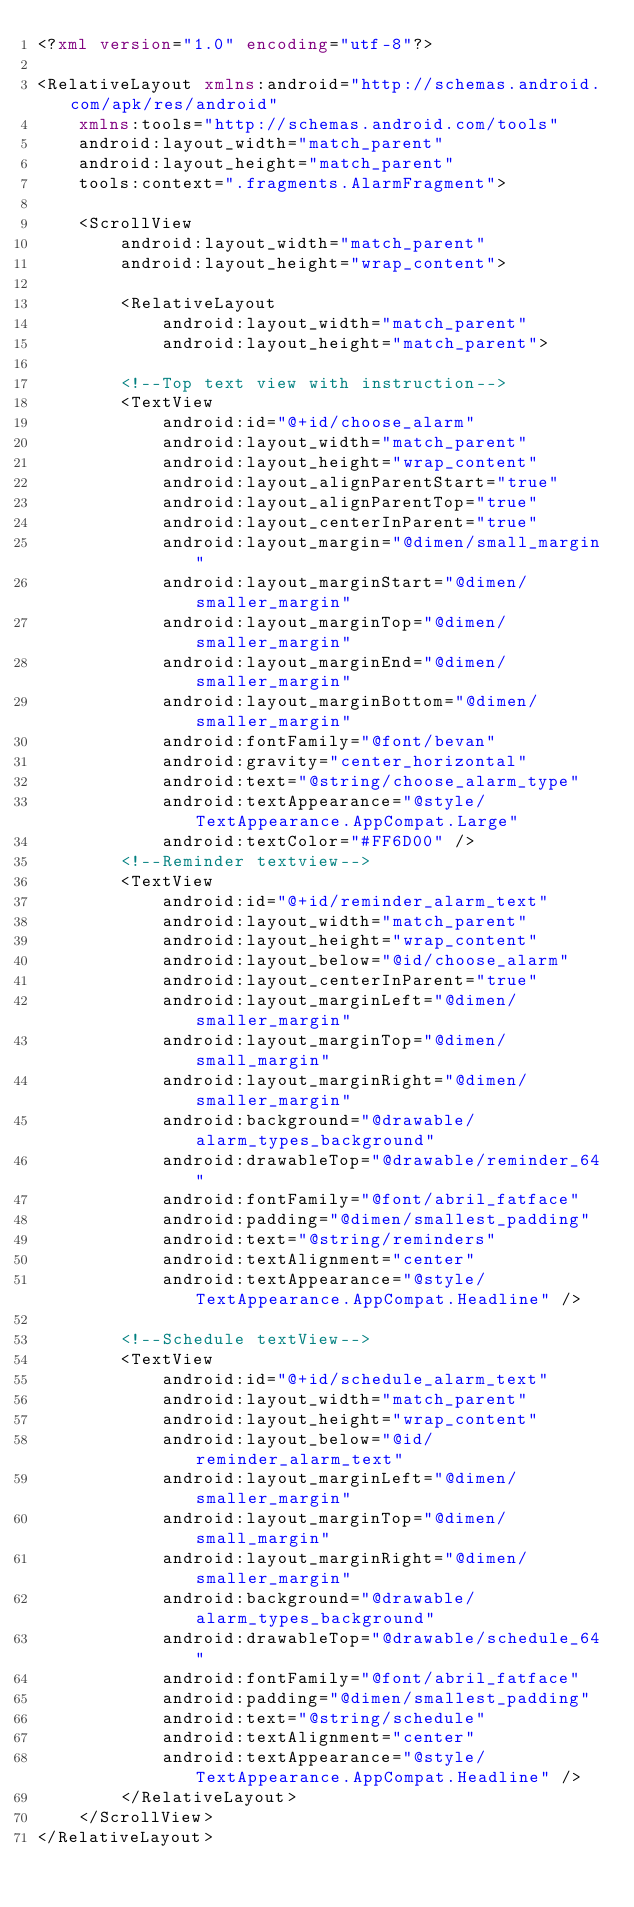Convert code to text. <code><loc_0><loc_0><loc_500><loc_500><_XML_><?xml version="1.0" encoding="utf-8"?>

<RelativeLayout xmlns:android="http://schemas.android.com/apk/res/android"
    xmlns:tools="http://schemas.android.com/tools"
    android:layout_width="match_parent"
    android:layout_height="match_parent"
    tools:context=".fragments.AlarmFragment">

    <ScrollView
        android:layout_width="match_parent"
        android:layout_height="wrap_content">

        <RelativeLayout
            android:layout_width="match_parent"
            android:layout_height="match_parent">

        <!--Top text view with instruction-->
        <TextView
            android:id="@+id/choose_alarm"
            android:layout_width="match_parent"
            android:layout_height="wrap_content"
            android:layout_alignParentStart="true"
            android:layout_alignParentTop="true"
            android:layout_centerInParent="true"
            android:layout_margin="@dimen/small_margin"
            android:layout_marginStart="@dimen/smaller_margin"
            android:layout_marginTop="@dimen/smaller_margin"
            android:layout_marginEnd="@dimen/smaller_margin"
            android:layout_marginBottom="@dimen/smaller_margin"
            android:fontFamily="@font/bevan"
            android:gravity="center_horizontal"
            android:text="@string/choose_alarm_type"
            android:textAppearance="@style/TextAppearance.AppCompat.Large"
            android:textColor="#FF6D00" />
        <!--Reminder textview-->
        <TextView
            android:id="@+id/reminder_alarm_text"
            android:layout_width="match_parent"
            android:layout_height="wrap_content"
            android:layout_below="@id/choose_alarm"
            android:layout_centerInParent="true"
            android:layout_marginLeft="@dimen/smaller_margin"
            android:layout_marginTop="@dimen/small_margin"
            android:layout_marginRight="@dimen/smaller_margin"
            android:background="@drawable/alarm_types_background"
            android:drawableTop="@drawable/reminder_64"
            android:fontFamily="@font/abril_fatface"
            android:padding="@dimen/smallest_padding"
            android:text="@string/reminders"
            android:textAlignment="center"
            android:textAppearance="@style/TextAppearance.AppCompat.Headline" />

        <!--Schedule textView-->
        <TextView
            android:id="@+id/schedule_alarm_text"
            android:layout_width="match_parent"
            android:layout_height="wrap_content"
            android:layout_below="@id/reminder_alarm_text"
            android:layout_marginLeft="@dimen/smaller_margin"
            android:layout_marginTop="@dimen/small_margin"
            android:layout_marginRight="@dimen/smaller_margin"
            android:background="@drawable/alarm_types_background"
            android:drawableTop="@drawable/schedule_64"
            android:fontFamily="@font/abril_fatface"
            android:padding="@dimen/smallest_padding"
            android:text="@string/schedule"
            android:textAlignment="center"
            android:textAppearance="@style/TextAppearance.AppCompat.Headline" />
        </RelativeLayout>
    </ScrollView>
</RelativeLayout>
</code> 